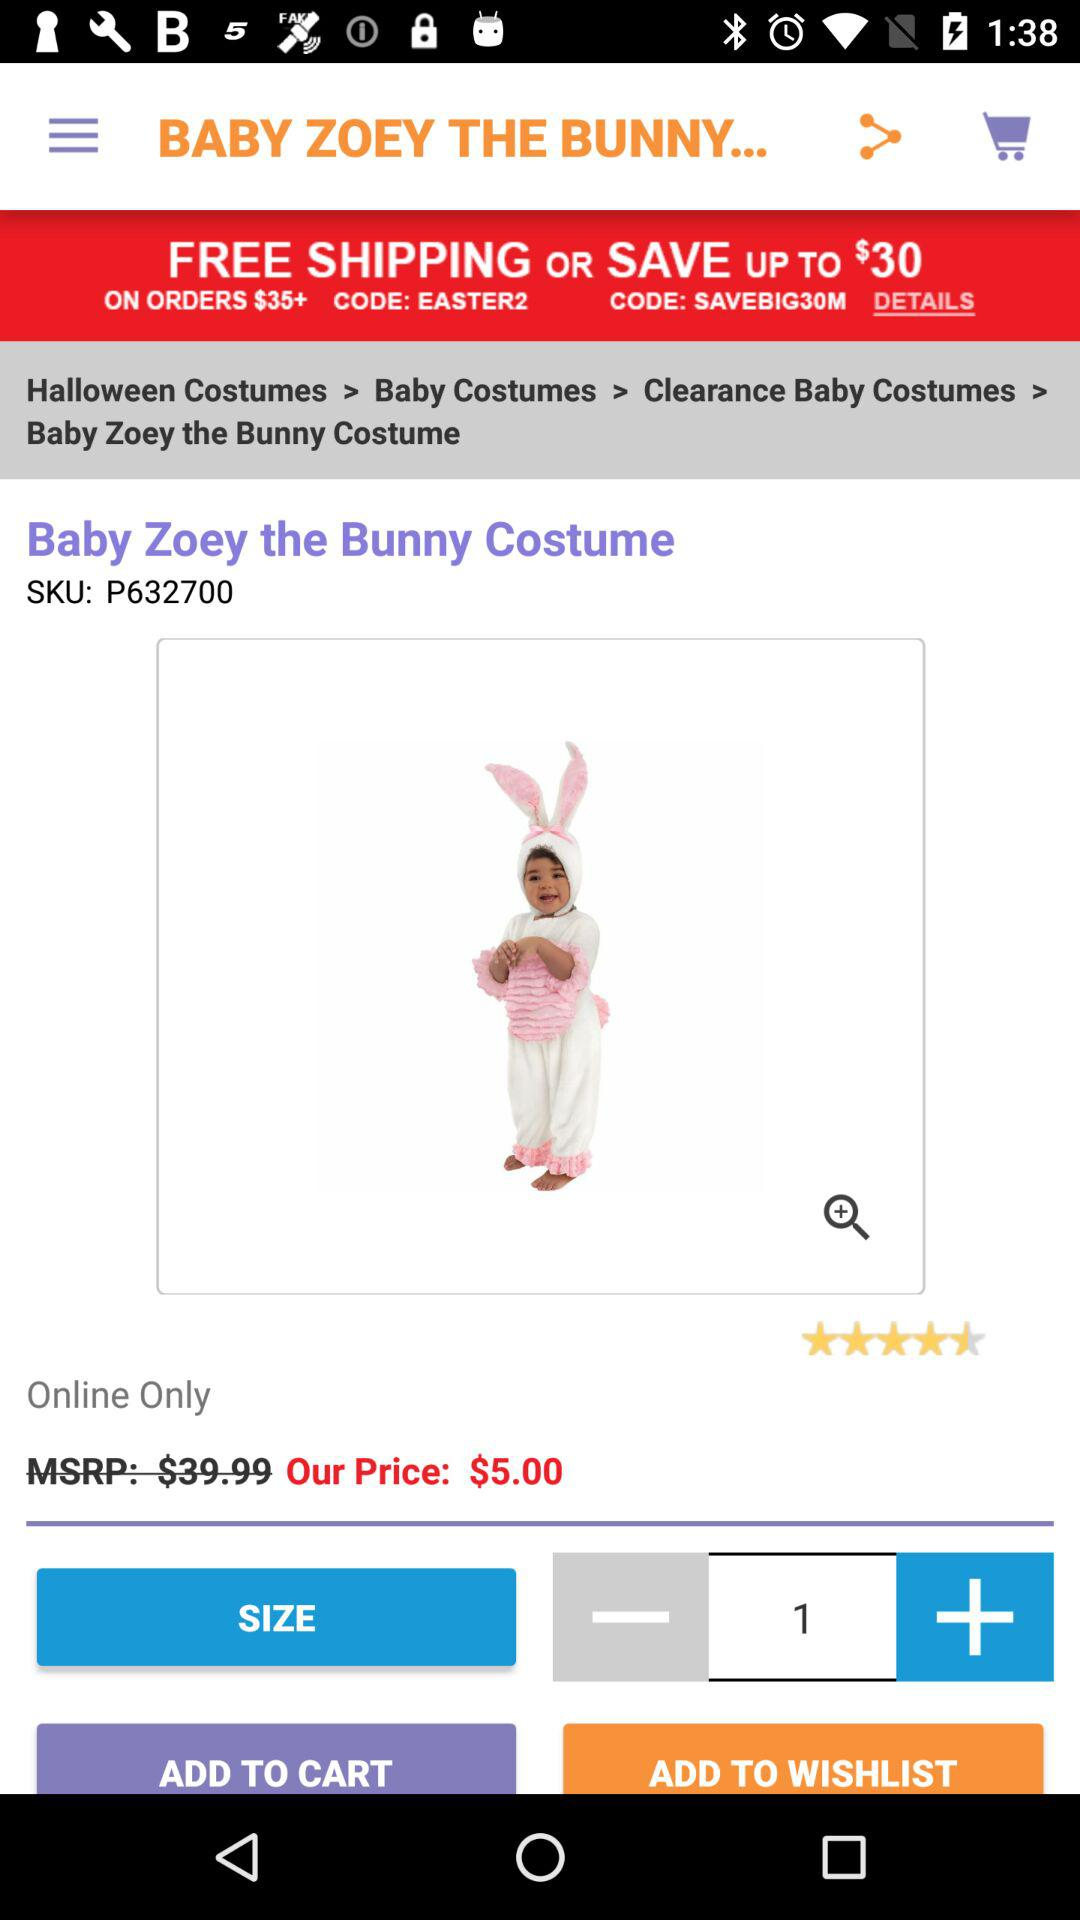What is the discounted price of "Baby Zoey the Bunny Costume"? The discounted price is $5. 